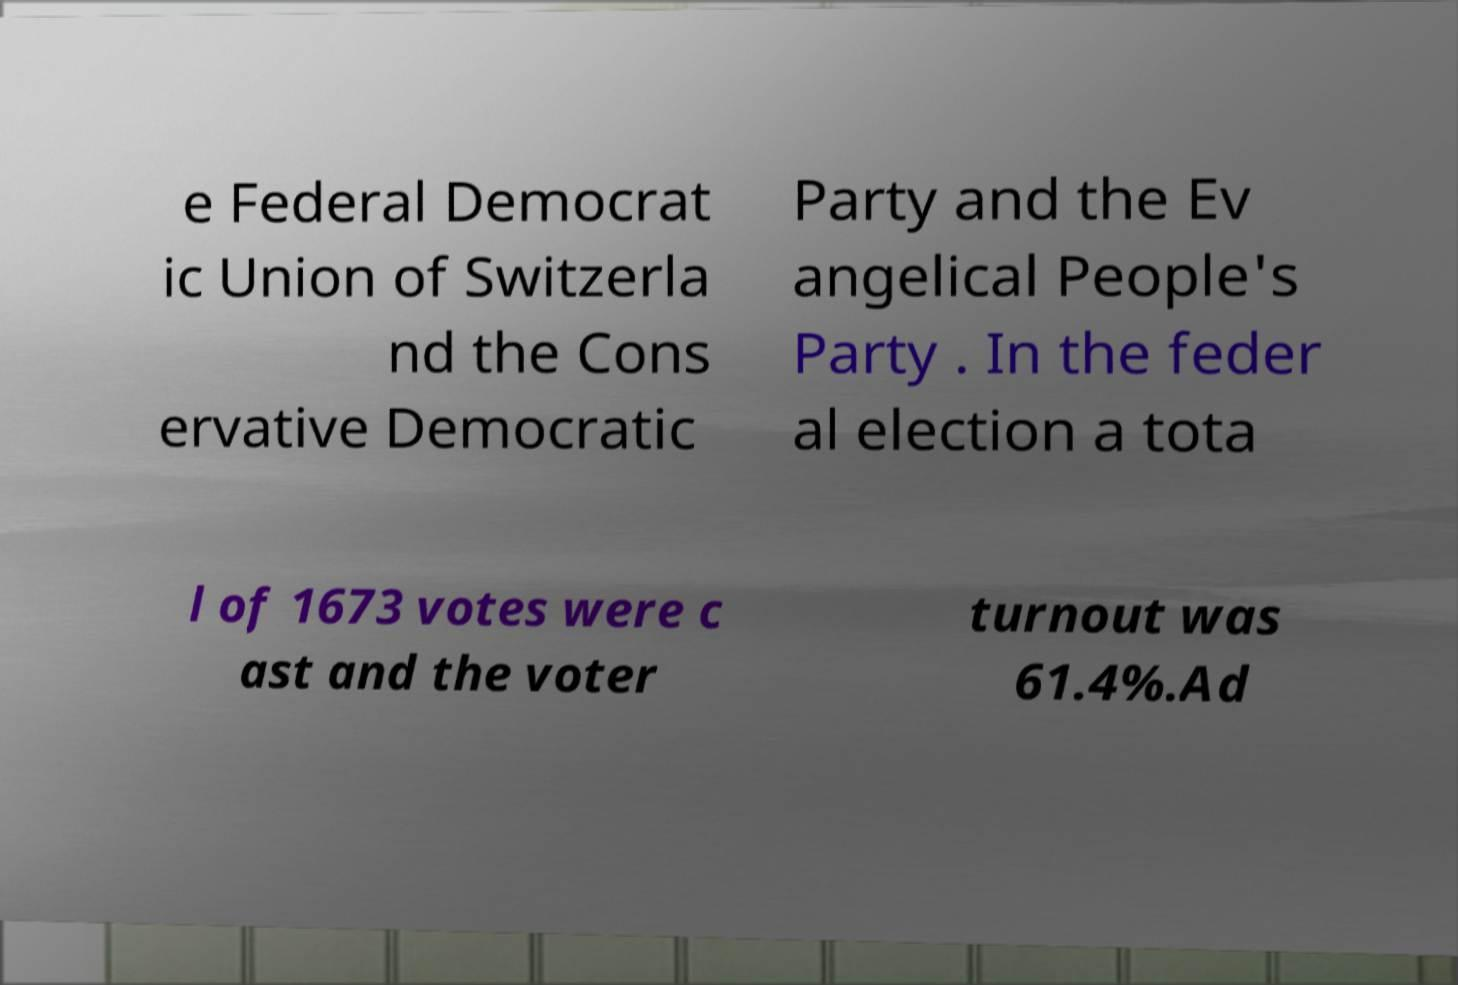Please read and relay the text visible in this image. What does it say? e Federal Democrat ic Union of Switzerla nd the Cons ervative Democratic Party and the Ev angelical People's Party . In the feder al election a tota l of 1673 votes were c ast and the voter turnout was 61.4%.Ad 